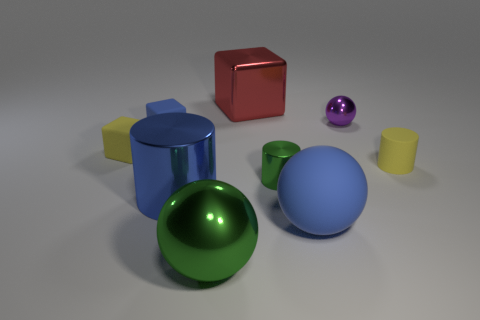Is there a pattern to the arrangement of objects in the image? The placement of the objects does not suggest a clear pattern at first glance. They appear to be scattered randomly across the surface, creating a dynamic composition. The varying sizes, colours, and shapes of the objects contribute to a sense of visual diversity without a discernible pattern.  What might be the purpose of arranging the objects this way? The purpose of such an arrangement could be several-fold. It may serve an artistic intent, showcasing the contrast and harmony among different shapes and colours. Alternatively, it might be part of an experiment or demonstration to study the properties of light and shadow, reflections, and material appearances under consistent lighting conditions. 